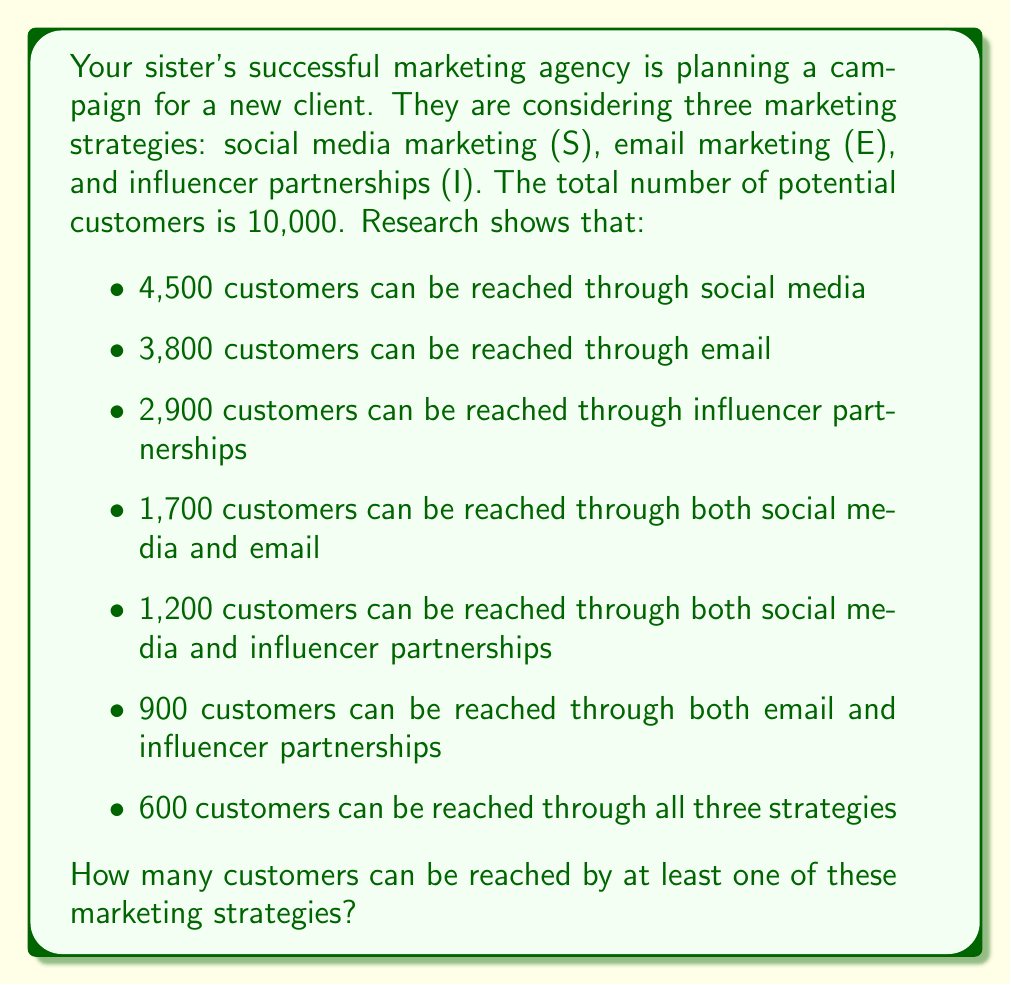Teach me how to tackle this problem. Let's approach this step-by-step using set theory and Venn diagrams:

1) First, let's draw a Venn diagram with three circles representing S, E, and I:

[asy]
unitsize(1cm);
pair A = (0,0), B = (1.5,0), C = (0.75,1.3);
real r = 1.2;
draw(circle(A,r));
draw(circle(B,r));
draw(circle(C,r));
label("S", A+(-0.8,-0.8));
label("E", B+(0.8,-0.8));
label("I", C+(0,1));
[/asy]

2) Now, let's fill in the known values:
   - 600 in the center (S ∩ E ∩ I)
   - 1,700 in S ∩ E
   - 1,200 in S ∩ I
   - 900 in E ∩ I

3) Let's use the inclusion-exclusion principle:
   $|S ∪ E ∪ I| = |S| + |E| + |I| - |S ∩ E| - |S ∩ I| - |E ∩ I| + |S ∩ E ∩ I|$

4) We know all these values except |S ∪ E ∪ I|, which is what we're trying to find:
   $|S ∪ E ∪ I| = 4500 + 3800 + 2900 - 1700 - 1200 - 900 + 600$

5) Let's calculate:
   $|S ∪ E ∪ I| = 11200 - 3800 + 600 = 8000$

Therefore, 8,000 customers can be reached by at least one of these marketing strategies.
Answer: 8,000 customers 